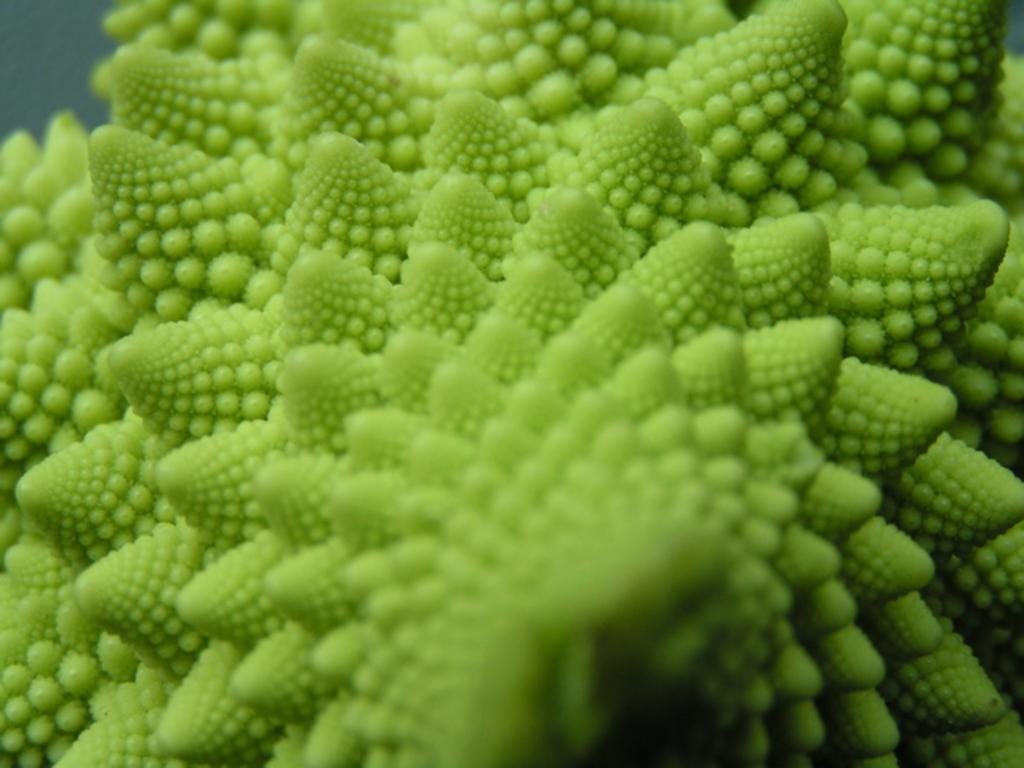What color is the main subject of the image? The picture in the image is green. Can you describe the structure of the picture? The picture has several layers. What do the corners of the picture resemble? The corners of the picture resemble plates. What might the image depict based on its appearance? The image may depict a bitter gourd. How many plants are growing from the seed in the image? There is no seed or plants present in the image; it features a green picture with several layers and plate-like corners. 